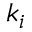Convert formula to latex. <formula><loc_0><loc_0><loc_500><loc_500>k _ { i }</formula> 